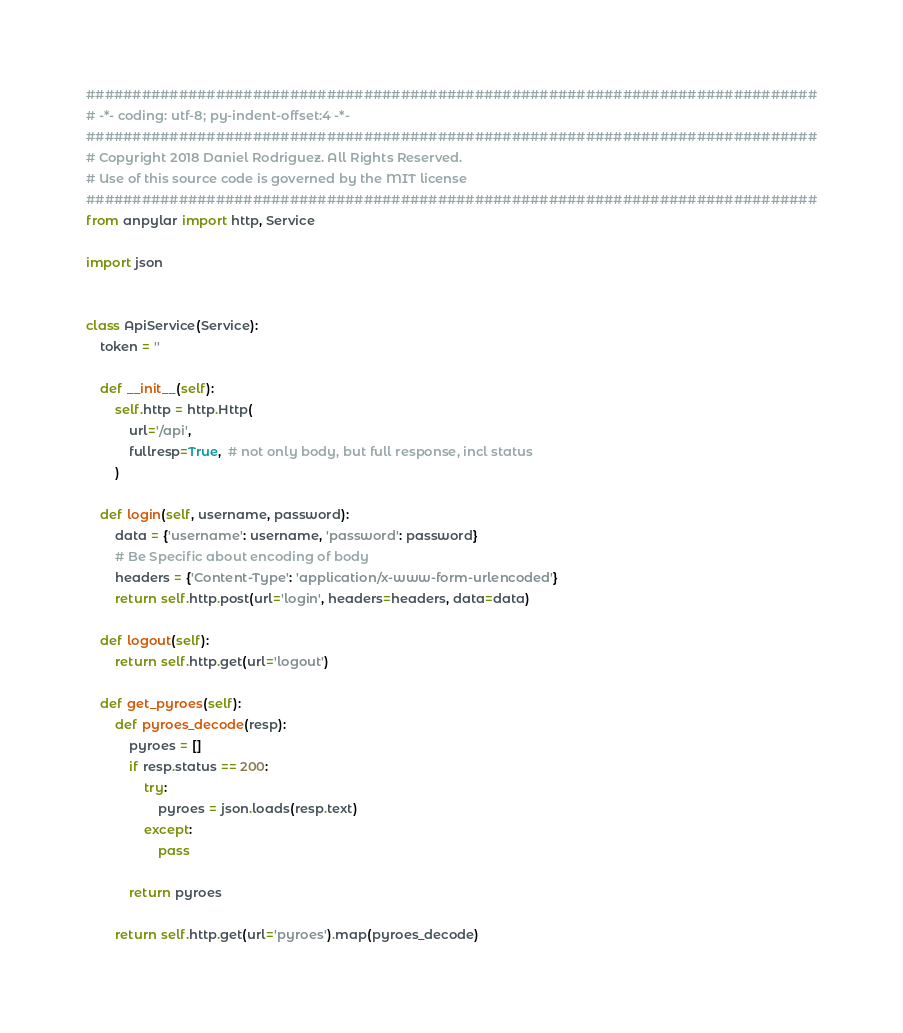<code> <loc_0><loc_0><loc_500><loc_500><_Python_>###############################################################################
# -*- coding: utf-8; py-indent-offset:4 -*-
###############################################################################
# Copyright 2018 Daniel Rodriguez. All Rights Reserved.
# Use of this source code is governed by the MIT license
###############################################################################
from anpylar import http, Service

import json


class ApiService(Service):
    token = ''

    def __init__(self):
        self.http = http.Http(
            url='/api',
            fullresp=True,  # not only body, but full response, incl status
        )

    def login(self, username, password):
        data = {'username': username, 'password': password}
        # Be Specific about encoding of body
        headers = {'Content-Type': 'application/x-www-form-urlencoded'}
        return self.http.post(url='login', headers=headers, data=data)

    def logout(self):
        return self.http.get(url='logout')

    def get_pyroes(self):
        def pyroes_decode(resp):
            pyroes = []
            if resp.status == 200:
                try:
                    pyroes = json.loads(resp.text)
                except:
                    pass

            return pyroes

        return self.http.get(url='pyroes').map(pyroes_decode)
</code> 